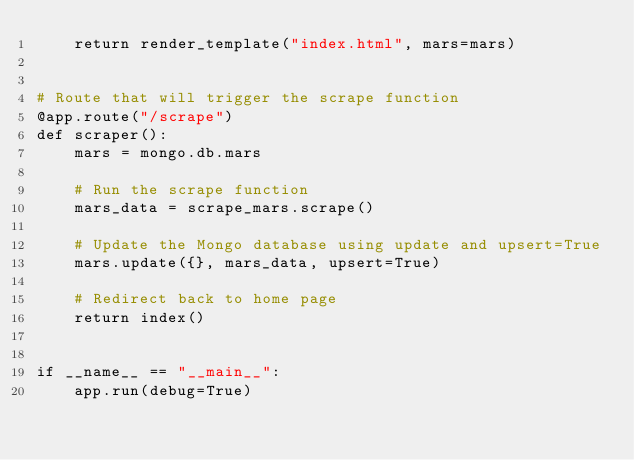Convert code to text. <code><loc_0><loc_0><loc_500><loc_500><_Python_>    return render_template("index.html", mars=mars)


# Route that will trigger the scrape function
@app.route("/scrape")
def scraper():
    mars = mongo.db.mars
    
    # Run the scrape function
    mars_data = scrape_mars.scrape()
    
    # Update the Mongo database using update and upsert=True
    mars.update({}, mars_data, upsert=True)
    
    # Redirect back to home page
    return index()


if __name__ == "__main__":
    app.run(debug=True)

</code> 